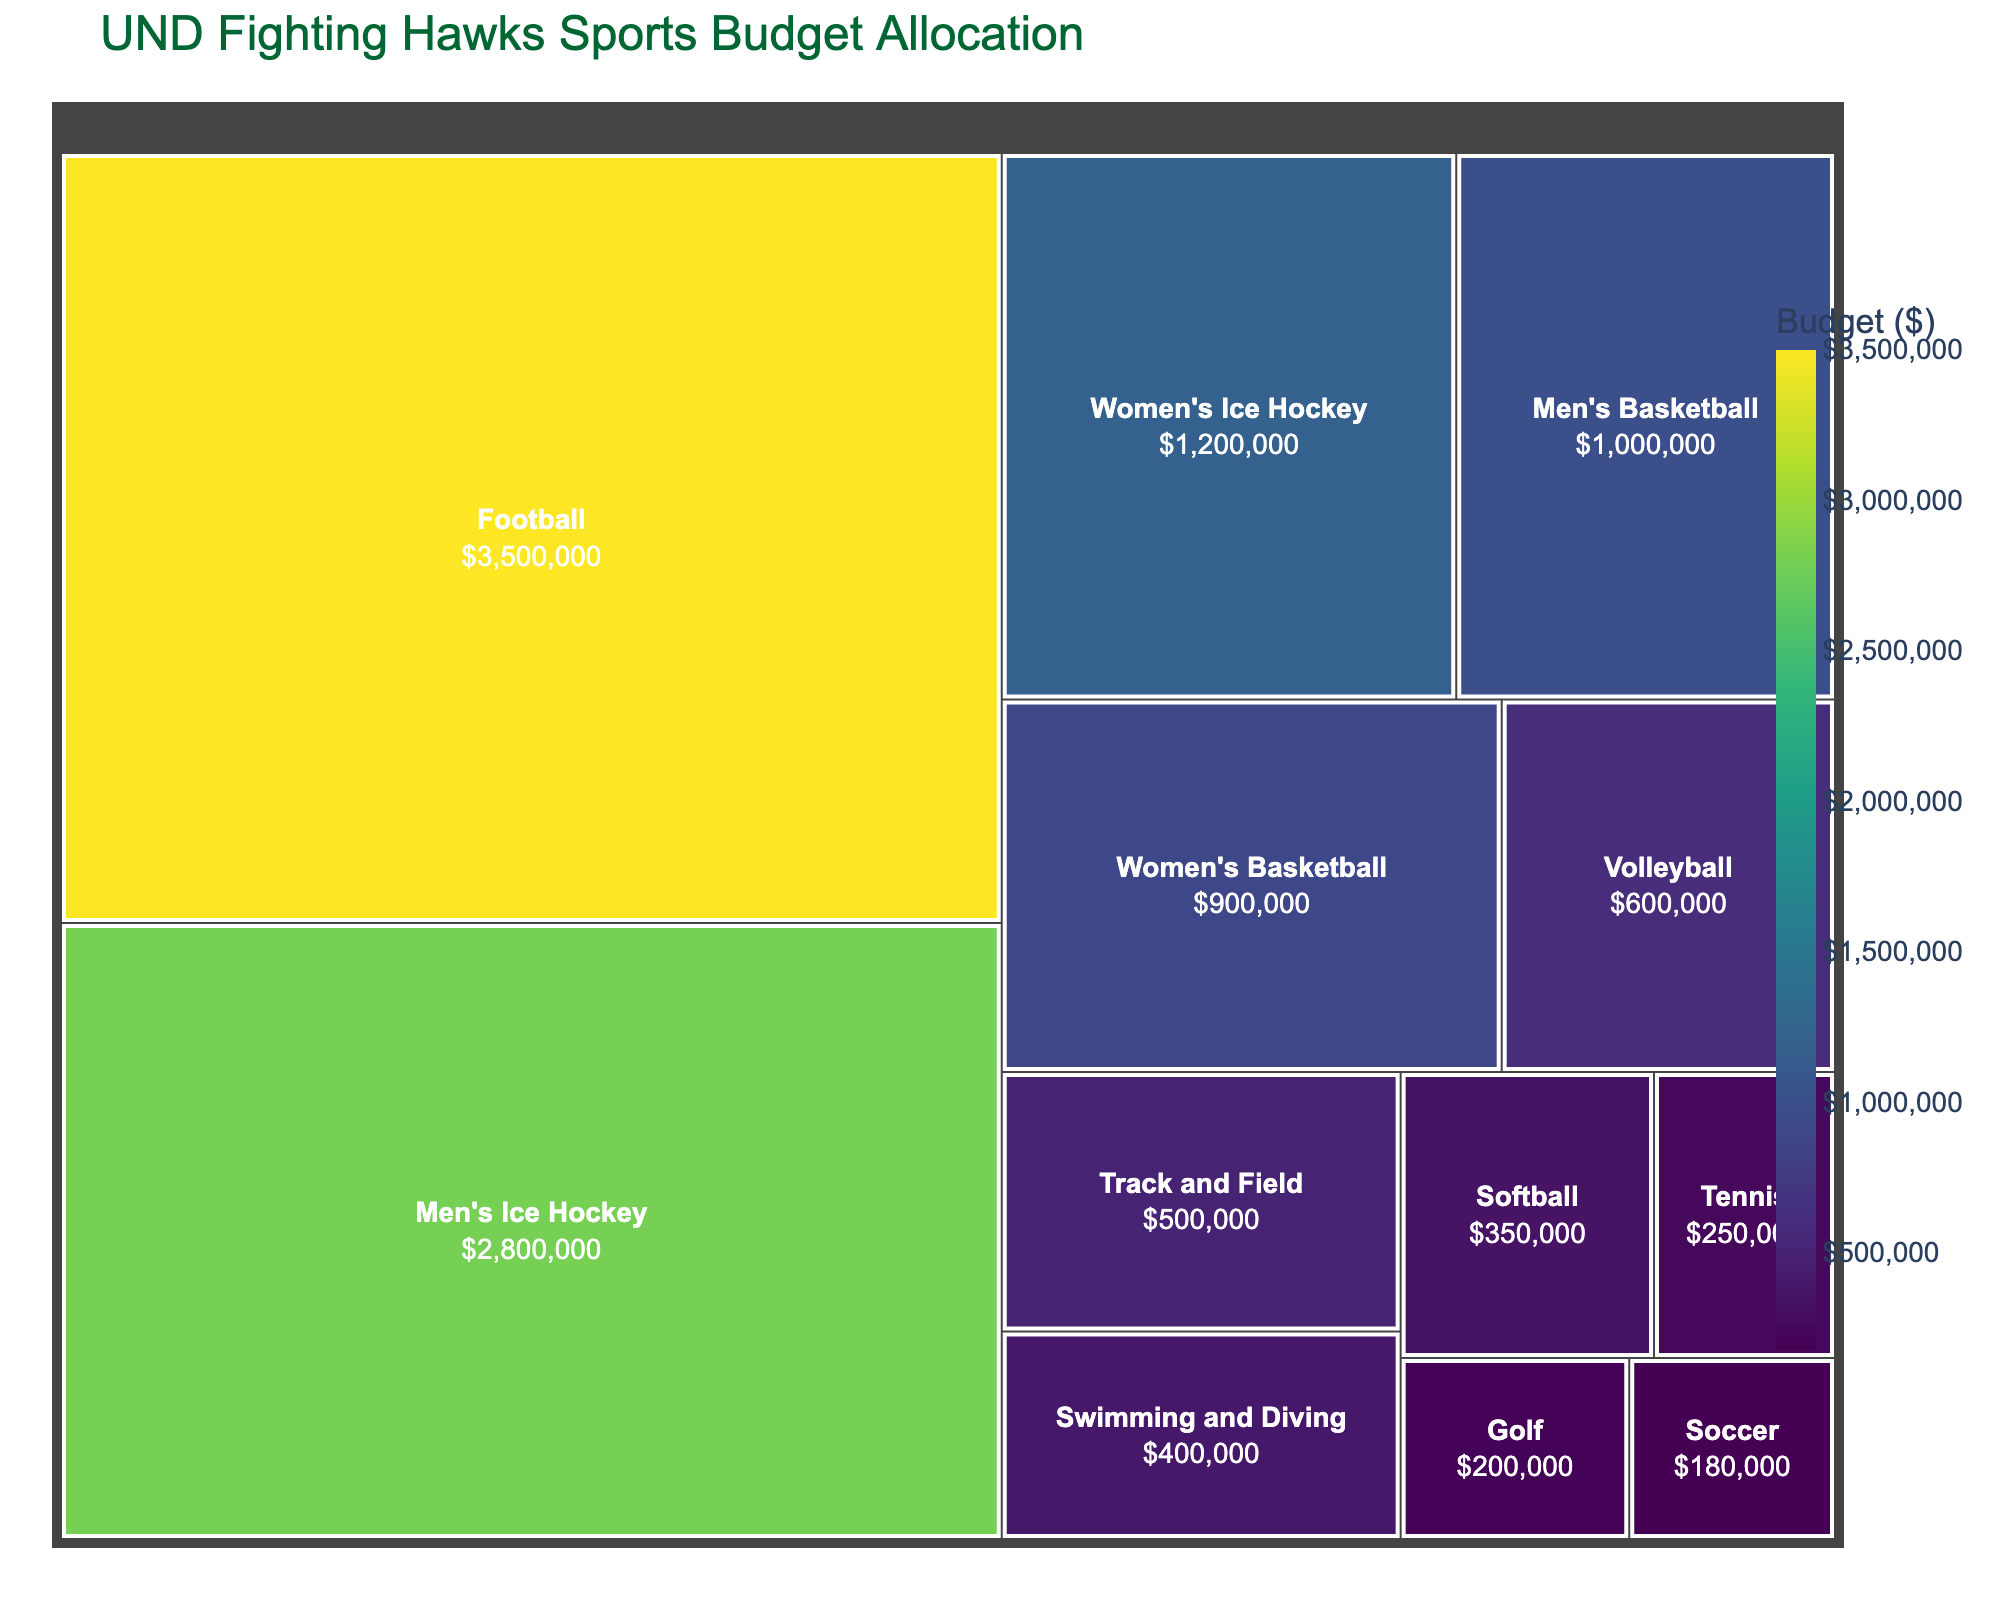What's the title of the treemap? The title is usually prominently displayed at the top of the treemap in a larger font size to give an overview of what the figure represents.
Answer: UND Fighting Hawks Sports Budget Allocation What is the total budget allocated across all sports departments? Sum the budgets of all departments: $3,500,000 (Football) + $2,800,000 (Men's Ice Hockey) + $1,200,000 (Women's Ice Hockey) + $1,000,000 (Men's Basketball) + $900,000 (Women's Basketball) + $600,000 (Volleyball) + $500,000 (Track and Field) + $400,000 (Swimming and Diving) + $350,000 (Softball) + $250,000 (Tennis) + $200,000 (Golf) + $180,000 (Soccer). The total is $11,880,000.
Answer: $11,880,000 Which department has the highest budget allocation? Look for the largest section in the treemap which should also be the darkest green, representing the highest budget value.
Answer: Football Which two departments have the closest budget allocation? Compare the sizes and values of each section in the treemap. Men's Basketball ($1,000,000) and Women's Basketball ($900,000) appear to be the closest in value.
Answer: Men's Basketball and Women's Basketball What is the budget difference between Men's Ice Hockey and Women's Ice Hockey? Subtract the budget of Women's Ice Hockey from Men's Ice Hockey: $2,800,000 - $1,200,000 = $1,600,000.
Answer: $1,600,000 How many departments have a budget allocation less than $500,000? Examine each section in the treemap to count departments: Swimming and Diving ($400,000), Softball ($350,000), Tennis ($250,000), Golf ($200,000), and Soccer ($180,000) all have budgets less than $500,000. There are 5 departments in total.
Answer: 5 What is the average budget allocation for all sports departments? Divide the total budget by the number of departments. Total budget is $11,880,000 and there are 12 departments. The average is $11,880,000 / 12 = $990,000.
Answer: $990,000 Which department has a larger budget: Volleyball or Track and Field? Compare the sizes and values of the sections representing Volleyball ($600,000) and Track and Field ($500,000). Volleyball has the larger budget.
Answer: Volleyball If the budget for Men's Ice Hockey is increased by $500,000, what will be its new budget? Add the increase to the current budget: $2,800,000 + $500,000 = $3,300,000.
Answer: $3,300,000 